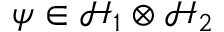<formula> <loc_0><loc_0><loc_500><loc_500>\psi \in { \mathcal { H } } _ { 1 } \otimes { \mathcal { H } } _ { 2 }</formula> 